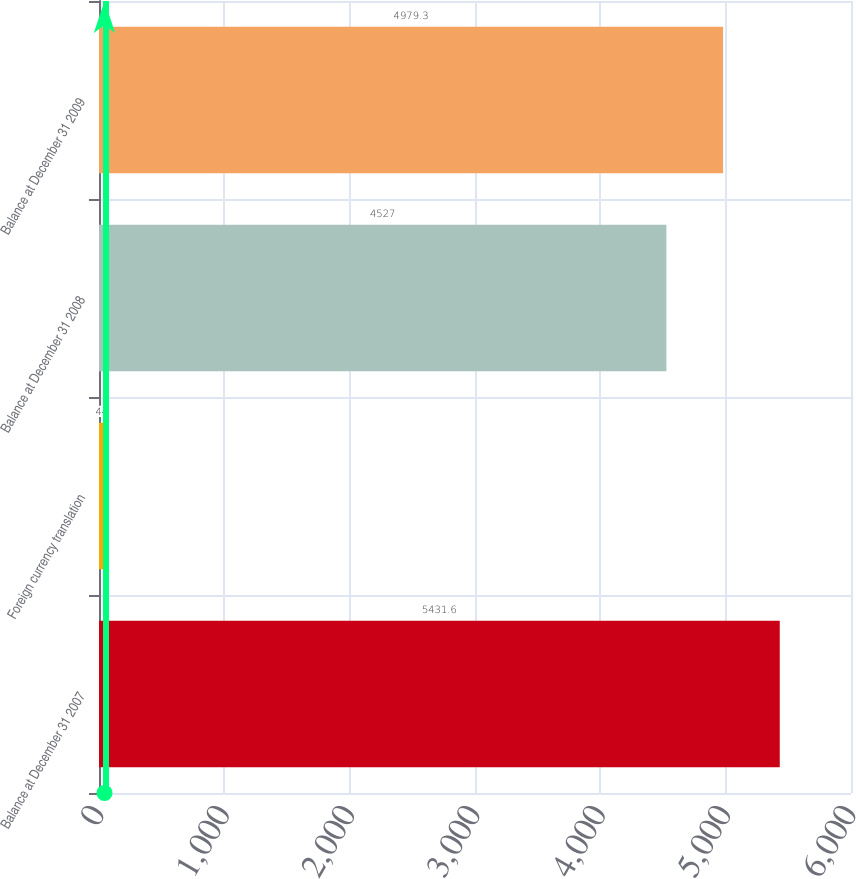Convert chart. <chart><loc_0><loc_0><loc_500><loc_500><bar_chart><fcel>Balance at December 31 2007<fcel>Foreign currency translation<fcel>Balance at December 31 2008<fcel>Balance at December 31 2009<nl><fcel>5431.6<fcel>44<fcel>4527<fcel>4979.3<nl></chart> 